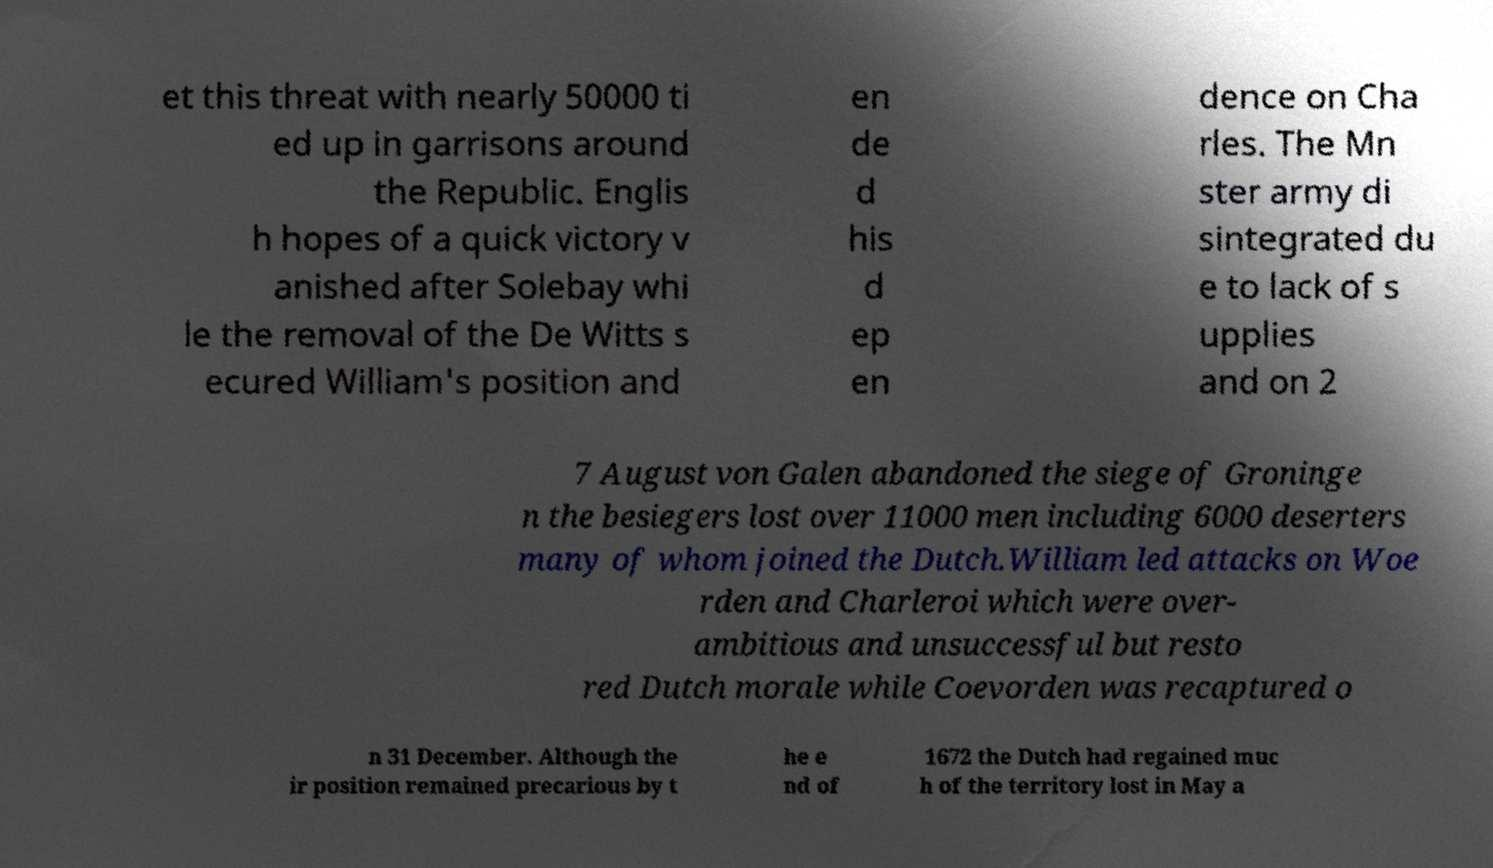Please read and relay the text visible in this image. What does it say? et this threat with nearly 50000 ti ed up in garrisons around the Republic. Englis h hopes of a quick victory v anished after Solebay whi le the removal of the De Witts s ecured William's position and en de d his d ep en dence on Cha rles. The Mn ster army di sintegrated du e to lack of s upplies and on 2 7 August von Galen abandoned the siege of Groninge n the besiegers lost over 11000 men including 6000 deserters many of whom joined the Dutch.William led attacks on Woe rden and Charleroi which were over- ambitious and unsuccessful but resto red Dutch morale while Coevorden was recaptured o n 31 December. Although the ir position remained precarious by t he e nd of 1672 the Dutch had regained muc h of the territory lost in May a 